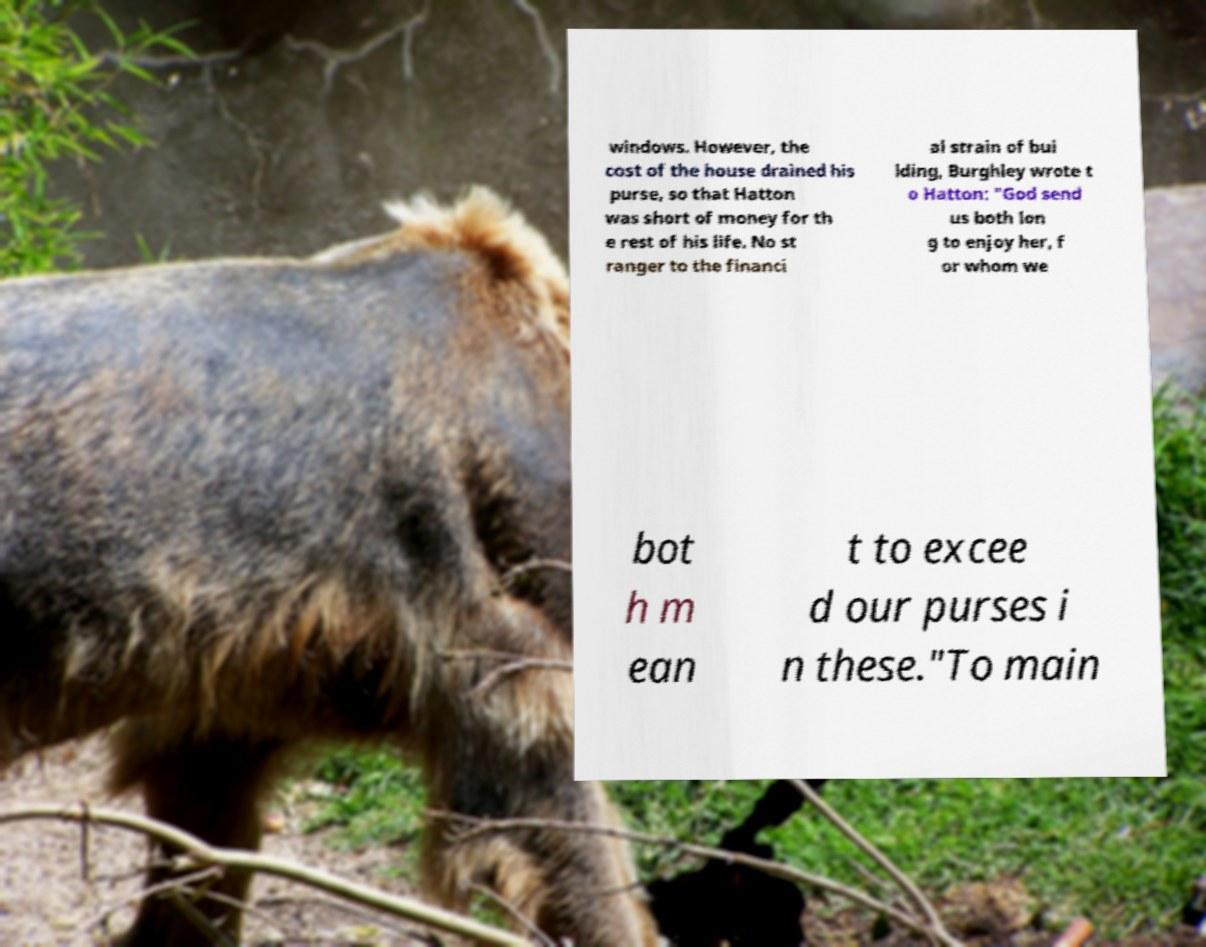Please read and relay the text visible in this image. What does it say? windows. However, the cost of the house drained his purse, so that Hatton was short of money for th e rest of his life. No st ranger to the financi al strain of bui lding, Burghley wrote t o Hatton: "God send us both lon g to enjoy her, f or whom we bot h m ean t to excee d our purses i n these."To main 